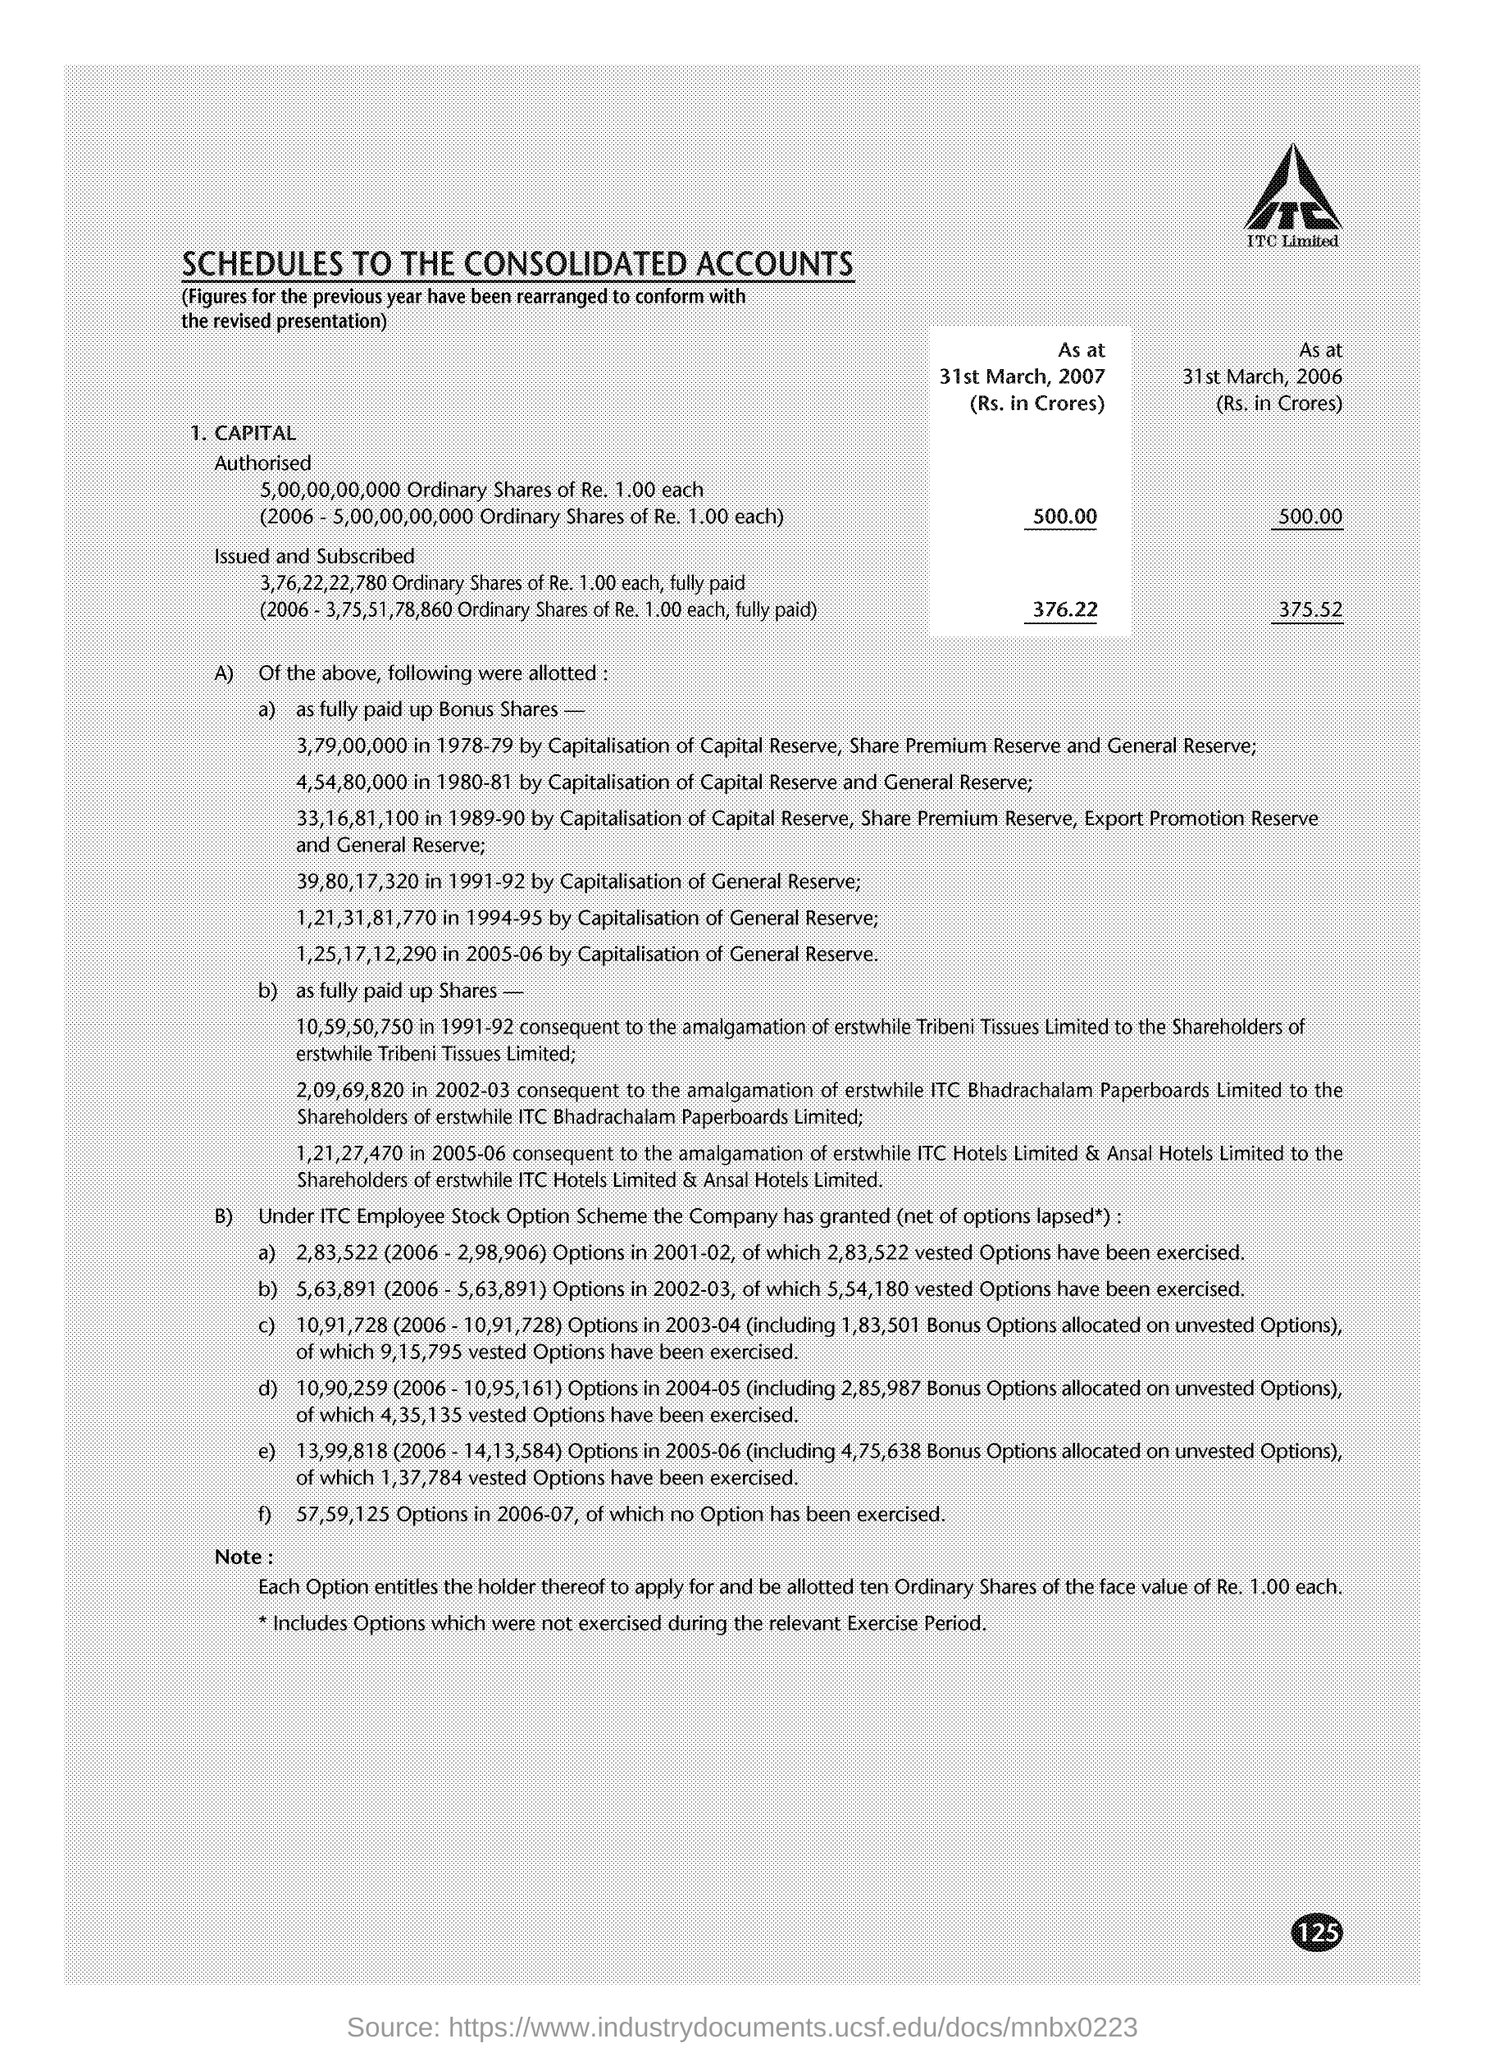Point out several critical features in this image. The total amount of issued and subscribed capital on March 31, 2006, was 375.52. The face value of one ordinary share is Re. 1.00. As of March 31, 2007, the authorized capital of the company was 500. 